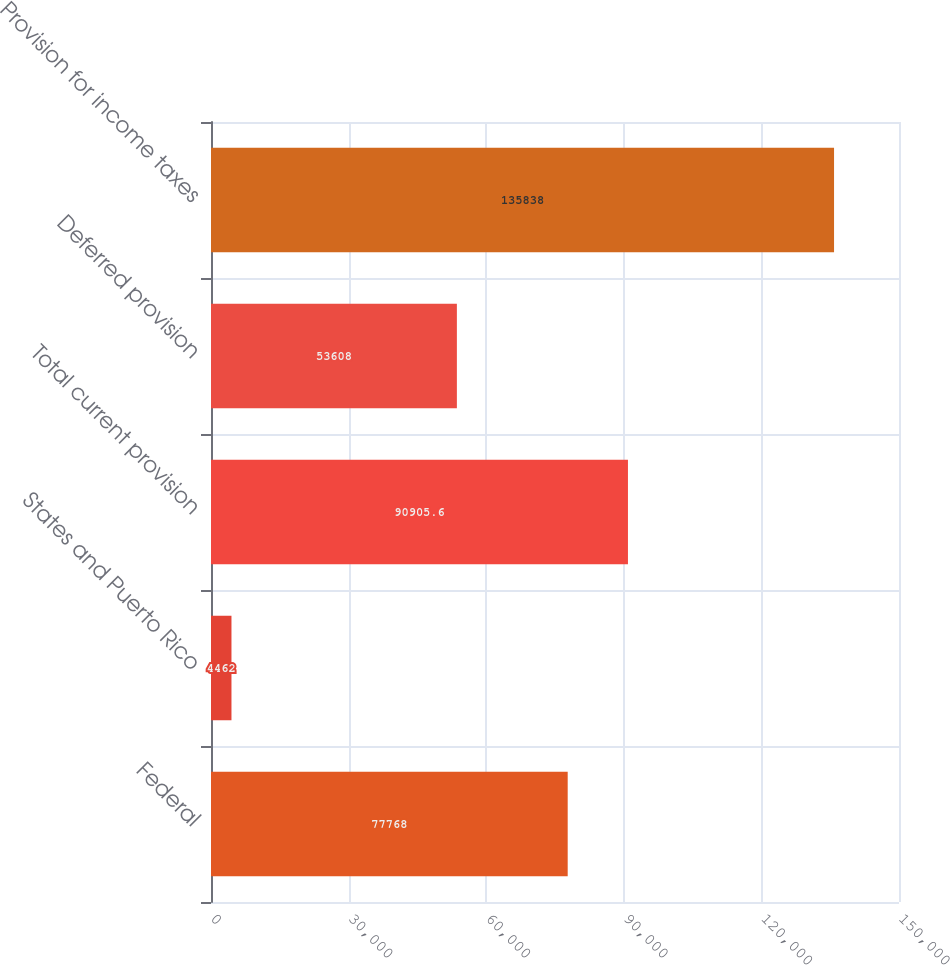Convert chart to OTSL. <chart><loc_0><loc_0><loc_500><loc_500><bar_chart><fcel>Federal<fcel>States and Puerto Rico<fcel>Total current provision<fcel>Deferred provision<fcel>Provision for income taxes<nl><fcel>77768<fcel>4462<fcel>90905.6<fcel>53608<fcel>135838<nl></chart> 